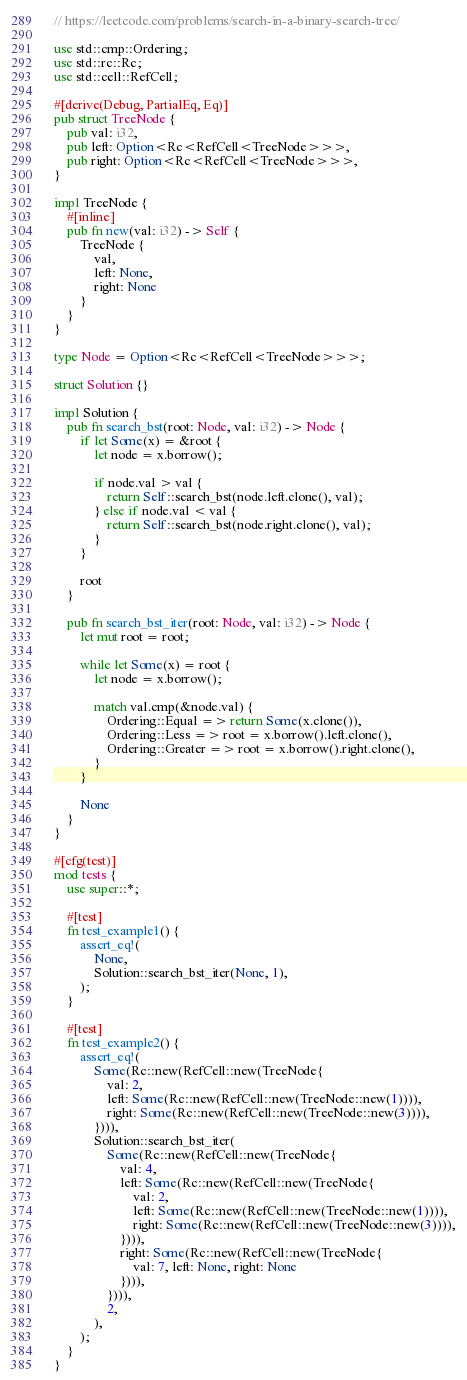Convert code to text. <code><loc_0><loc_0><loc_500><loc_500><_Rust_>// https://leetcode.com/problems/search-in-a-binary-search-tree/

use std::cmp::Ordering;
use std::rc::Rc;
use std::cell::RefCell;

#[derive(Debug, PartialEq, Eq)]
pub struct TreeNode {
    pub val: i32,
    pub left: Option<Rc<RefCell<TreeNode>>>,
    pub right: Option<Rc<RefCell<TreeNode>>>,
}

impl TreeNode {
    #[inline]
    pub fn new(val: i32) -> Self {
        TreeNode {
            val,
            left: None,
            right: None
        }
    }
}

type Node = Option<Rc<RefCell<TreeNode>>>;

struct Solution {}

impl Solution {
    pub fn search_bst(root: Node, val: i32) -> Node {
        if let Some(x) = &root {
            let node = x.borrow();

            if node.val > val {
                return Self::search_bst(node.left.clone(), val);
            } else if node.val < val {
                return Self::search_bst(node.right.clone(), val);
            }
        }

        root
    }

    pub fn search_bst_iter(root: Node, val: i32) -> Node {
        let mut root = root;

        while let Some(x) = root {
            let node = x.borrow();

            match val.cmp(&node.val) {
                Ordering::Equal => return Some(x.clone()),
                Ordering::Less => root = x.borrow().left.clone(),
                Ordering::Greater => root = x.borrow().right.clone(),
            }
        }

        None
    }
}

#[cfg(test)]
mod tests {
    use super::*;

    #[test]
    fn test_example1() {
        assert_eq!(
            None,
            Solution::search_bst_iter(None, 1),
        );
    }

    #[test]
    fn test_example2() {
        assert_eq!(
            Some(Rc::new(RefCell::new(TreeNode{
                val: 2,
                left: Some(Rc::new(RefCell::new(TreeNode::new(1)))),
                right: Some(Rc::new(RefCell::new(TreeNode::new(3)))),
            }))),
            Solution::search_bst_iter(
                Some(Rc::new(RefCell::new(TreeNode{
                    val: 4,
                    left: Some(Rc::new(RefCell::new(TreeNode{
                        val: 2,
                        left: Some(Rc::new(RefCell::new(TreeNode::new(1)))),
                        right: Some(Rc::new(RefCell::new(TreeNode::new(3)))),
                    }))),
                    right: Some(Rc::new(RefCell::new(TreeNode{
                        val: 7, left: None, right: None
                    }))),
                }))),
                2,
            ),
        );
    }
}
</code> 